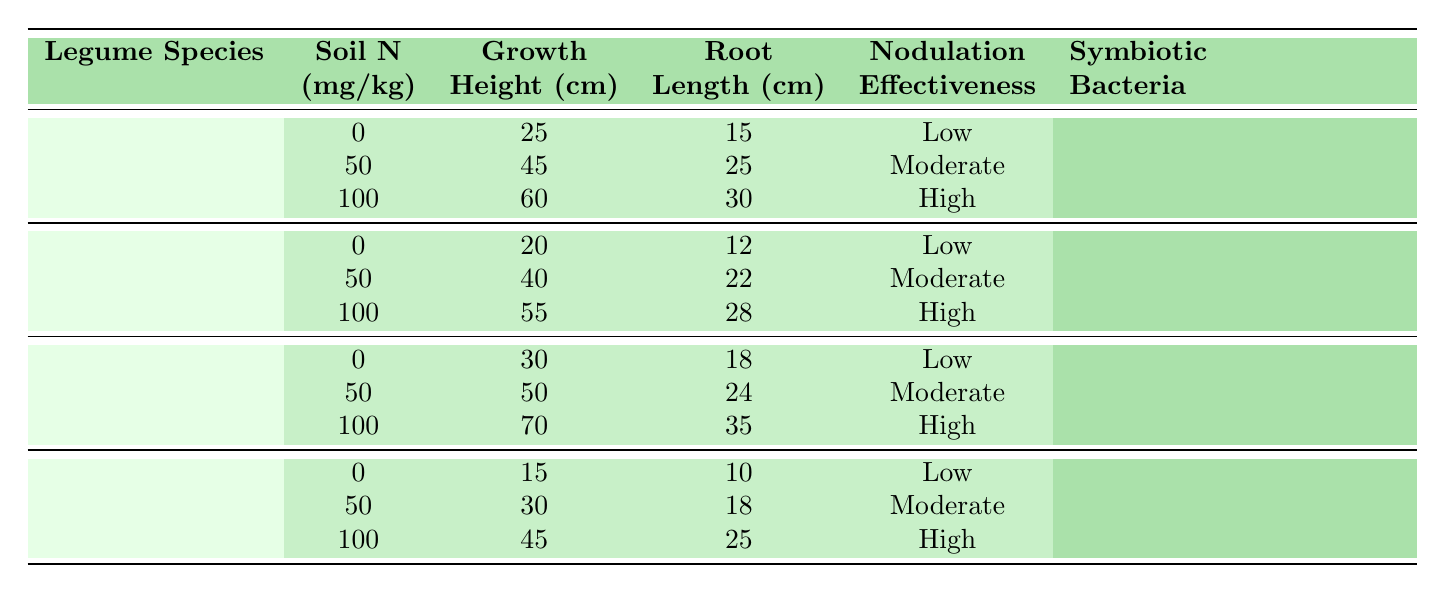What is the growth height of Phaseolus vulgaris at a soil nitrogen level of 100 mg/kg? The table shows that the growth height of Phaseolus vulgaris at 100 mg/kg soil nitrogen level is recorded as 60 cm.
Answer: 60 cm What is the root length of Glycine max at a soil nitrogen level of 50 mg/kg? According to the table, the root length of Glycine max at 50 mg/kg soil nitrogen level is 22 cm.
Answer: 22 cm Does Cicer arietinum show high nodulation effectiveness at a soil nitrogen level of 0 mg/kg? The table indicates that Cicer arietinum has a low nodulation effectiveness at a nitrogen level of 0 mg/kg, so the statement is false.
Answer: No What is the average growth height of legumes across all species at a nitrogen level of 50 mg/kg? The growth heights at 50 mg/kg are 45 cm (Phaseolus vulgaris), 40 cm (Glycine max), 50 cm (Medicago sativa), and 30 cm (Cicer arietinum). The average is (45 + 40 + 50 + 30) / 4 = 41.25 cm.
Answer: 41.25 cm Is Rhizobium phaseoli the symbiotic bacteria for both Phaseolus vulgaris and Cicer arietinum? The table specifies that Rhizobium phaseoli is associated with Phaseolus vulgaris, while Cicer arietinum is associated with Rhizobium ciceri, making the statement false.
Answer: No What is the difference in growth height between Medicago sativa at 0 mg/kg and at 100 mg/kg? The growth height of Medicago sativa at 0 mg/kg is 30 cm, while at 100 mg/kg it is 70 cm. The difference is 70 cm - 30 cm = 40 cm.
Answer: 40 cm How does the nodulation effectiveness of legumes change with increasing soil nitrogen levels? The table indicates that for each legume species, as the nitrogen level increases from 0 to 100 mg/kg, the nodulation effectiveness improves from Low to High consistently.
Answer: Increases from Low to High Which legume species has the highest root length at 50 mg/kg soil nitrogen? The root lengths at 50 mg/kg are 25 cm (Phaseolus vulgaris), 22 cm (Glycine max), 24 cm (Medicago sativa), and 18 cm (Cicer arietinum). The highest is 25 cm for Phaseolus vulgaris.
Answer: Phaseolus vulgaris At which soil nitrogen level does Glycine max exhibit high nodulation effectiveness? The table shows that Glycine max exhibits high nodulation effectiveness at a soil nitrogen level of 100 mg/kg.
Answer: 100 mg/kg 